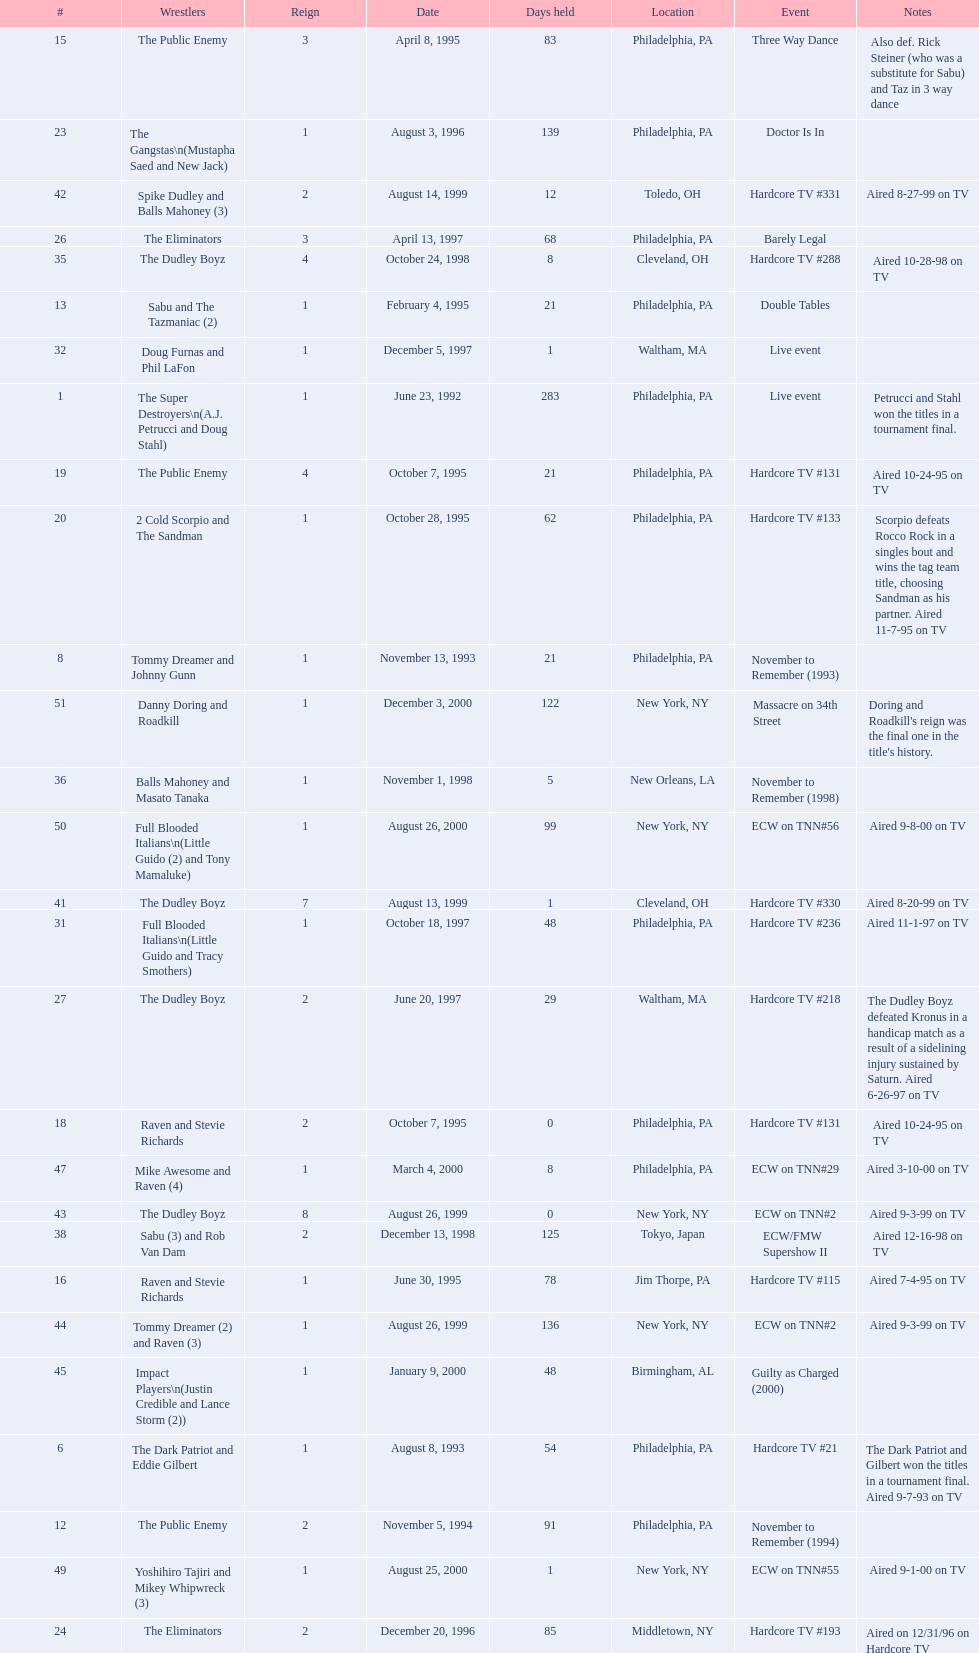Who maintained the title the greatest number of times, the super destroyers or the dudley boyz? The Dudley Boyz. 